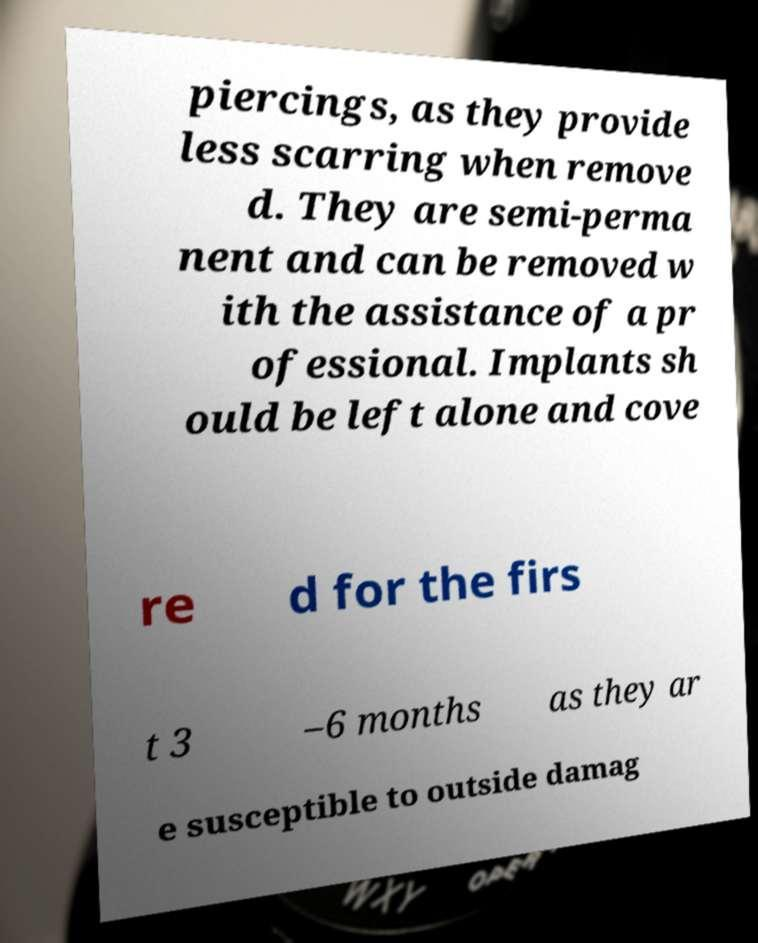Could you assist in decoding the text presented in this image and type it out clearly? piercings, as they provide less scarring when remove d. They are semi-perma nent and can be removed w ith the assistance of a pr ofessional. Implants sh ould be left alone and cove re d for the firs t 3 –6 months as they ar e susceptible to outside damag 